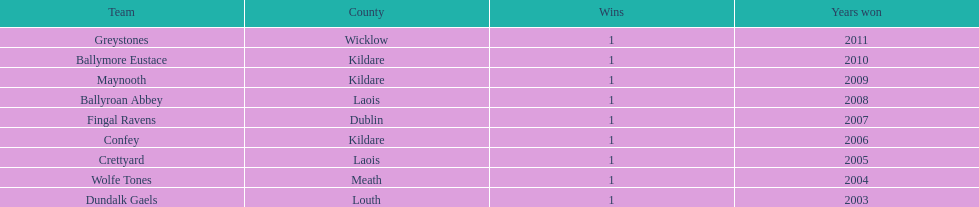Which is the foremost team from the graph? Greystones. 